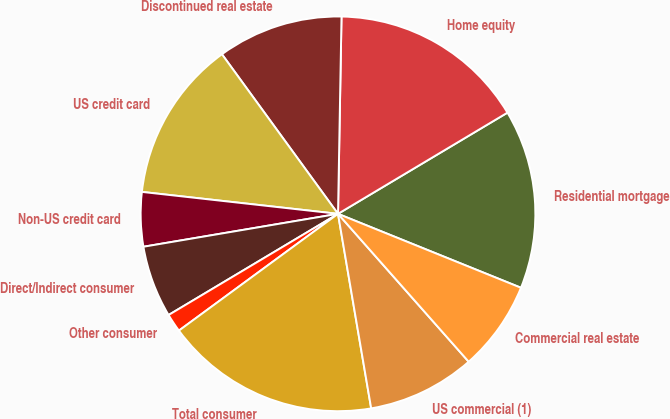Convert chart to OTSL. <chart><loc_0><loc_0><loc_500><loc_500><pie_chart><fcel>Residential mortgage<fcel>Home equity<fcel>Discontinued real estate<fcel>US credit card<fcel>Non-US credit card<fcel>Direct/Indirect consumer<fcel>Other consumer<fcel>Total consumer<fcel>US commercial (1)<fcel>Commercial real estate<nl><fcel>14.68%<fcel>16.15%<fcel>10.29%<fcel>13.22%<fcel>4.44%<fcel>5.9%<fcel>1.51%<fcel>17.61%<fcel>8.83%<fcel>7.37%<nl></chart> 